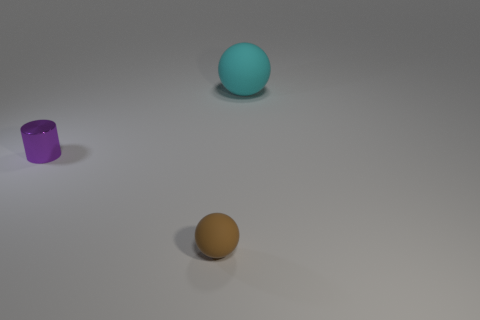Add 3 small yellow blocks. How many objects exist? 6 Subtract all cylinders. How many objects are left? 2 Subtract 0 green cylinders. How many objects are left? 3 Subtract all small metallic things. Subtract all purple shiny things. How many objects are left? 1 Add 1 matte balls. How many matte balls are left? 3 Add 2 large purple rubber things. How many large purple rubber things exist? 2 